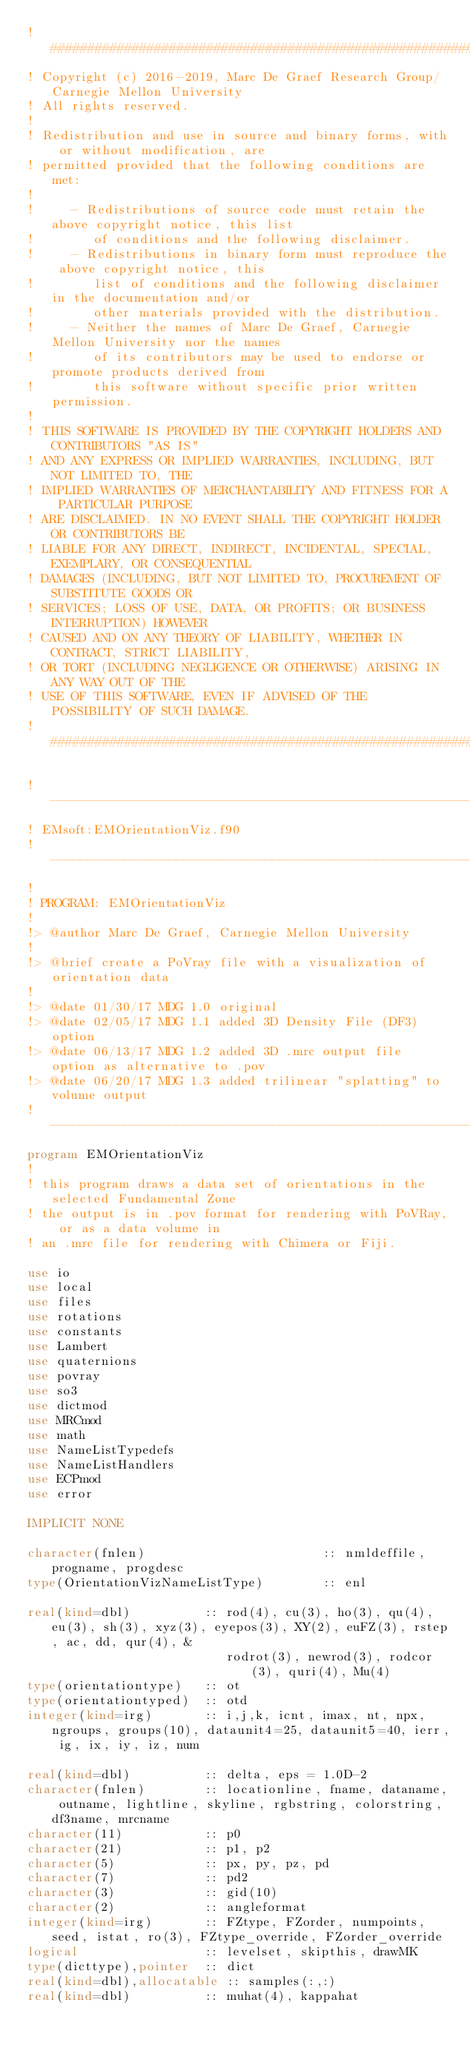<code> <loc_0><loc_0><loc_500><loc_500><_FORTRAN_>! ###################################################################
! Copyright (c) 2016-2019, Marc De Graef Research Group/Carnegie Mellon University
! All rights reserved.
!
! Redistribution and use in source and binary forms, with or without modification, are 
! permitted provided that the following conditions are met:
!
!     - Redistributions of source code must retain the above copyright notice, this list 
!        of conditions and the following disclaimer.
!     - Redistributions in binary form must reproduce the above copyright notice, this 
!        list of conditions and the following disclaimer in the documentation and/or 
!        other materials provided with the distribution.
!     - Neither the names of Marc De Graef, Carnegie Mellon University nor the names 
!        of its contributors may be used to endorse or promote products derived from 
!        this software without specific prior written permission.
!
! THIS SOFTWARE IS PROVIDED BY THE COPYRIGHT HOLDERS AND CONTRIBUTORS "AS IS" 
! AND ANY EXPRESS OR IMPLIED WARRANTIES, INCLUDING, BUT NOT LIMITED TO, THE 
! IMPLIED WARRANTIES OF MERCHANTABILITY AND FITNESS FOR A PARTICULAR PURPOSE 
! ARE DISCLAIMED. IN NO EVENT SHALL THE COPYRIGHT HOLDER OR CONTRIBUTORS BE 
! LIABLE FOR ANY DIRECT, INDIRECT, INCIDENTAL, SPECIAL, EXEMPLARY, OR CONSEQUENTIAL 
! DAMAGES (INCLUDING, BUT NOT LIMITED TO, PROCUREMENT OF SUBSTITUTE GOODS OR 
! SERVICES; LOSS OF USE, DATA, OR PROFITS; OR BUSINESS INTERRUPTION) HOWEVER 
! CAUSED AND ON ANY THEORY OF LIABILITY, WHETHER IN CONTRACT, STRICT LIABILITY, 
! OR TORT (INCLUDING NEGLIGENCE OR OTHERWISE) ARISING IN ANY WAY OUT OF THE 
! USE OF THIS SOFTWARE, EVEN IF ADVISED OF THE POSSIBILITY OF SUCH DAMAGE.
! ###################################################################

!--------------------------------------------------------------------------
! EMsoft:EMOrientationViz.f90
!--------------------------------------------------------------------------
!
! PROGRAM: EMOrientationViz
!
!> @author Marc De Graef, Carnegie Mellon University
!
!> @brief create a PoVray file with a visualization of orientation data
!
!> @date 01/30/17 MDG 1.0 original
!> @date 02/05/17 MDG 1.1 added 3D Density File (DF3) option
!> @date 06/13/17 MDG 1.2 added 3D .mrc output file option as alternative to .pov
!> @date 06/20/17 MDG 1.3 added trilinear "splatting" to volume output
!--------------------------------------------------------------------------
program EMOrientationViz
! 
! this program draws a data set of orientations in the selected Fundamental Zone
! the output is in .pov format for rendering with PoVRay, or as a data volume in
! an .mrc file for rendering with Chimera or Fiji.

use io
use local
use files
use rotations
use constants
use Lambert
use quaternions
use povray
use so3
use dictmod
use MRCmod
use math
use NameListTypedefs
use NameListHandlers
use ECPmod
use error

IMPLICIT NONE

character(fnlen)                        :: nmldeffile, progname, progdesc
type(OrientationVizNameListType)        :: enl

real(kind=dbl)          :: rod(4), cu(3), ho(3), qu(4), eu(3), sh(3), xyz(3), eyepos(3), XY(2), euFZ(3), rstep, ac, dd, qur(4), &
                           rodrot(3), newrod(3), rodcor(3), quri(4), Mu(4)
type(orientationtype)   :: ot
type(orientationtyped)  :: otd
integer(kind=irg)       :: i,j,k, icnt, imax, nt, npx, ngroups, groups(10), dataunit4=25, dataunit5=40, ierr, ig, ix, iy, iz, num

real(kind=dbl)          :: delta, eps = 1.0D-2
character(fnlen)        :: locationline, fname, dataname, outname, lightline, skyline, rgbstring, colorstring, df3name, mrcname
character(11)           :: p0
character(21)           :: p1, p2
character(5)            :: px, py, pz, pd
character(7)            :: pd2
character(3)            :: gid(10)
character(2)            :: angleformat
integer(kind=irg)       :: FZtype, FZorder, numpoints, seed, istat, ro(3), FZtype_override, FZorder_override
logical                 :: levelset, skipthis, drawMK
type(dicttype),pointer  :: dict
real(kind=dbl),allocatable :: samples(:,:)
real(kind=dbl)          :: muhat(4), kappahat</code> 